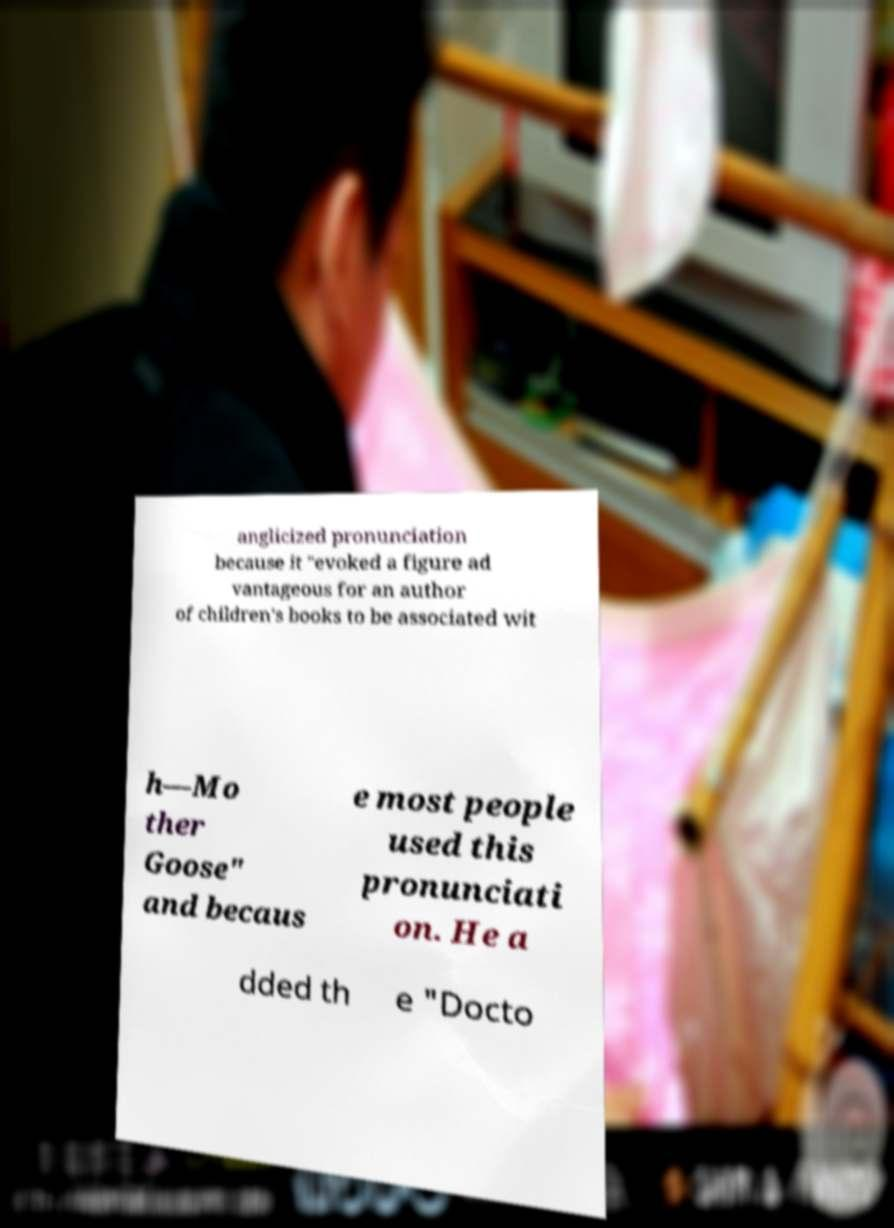Can you read and provide the text displayed in the image?This photo seems to have some interesting text. Can you extract and type it out for me? anglicized pronunciation because it "evoked a figure ad vantageous for an author of children's books to be associated wit h—Mo ther Goose" and becaus e most people used this pronunciati on. He a dded th e "Docto 